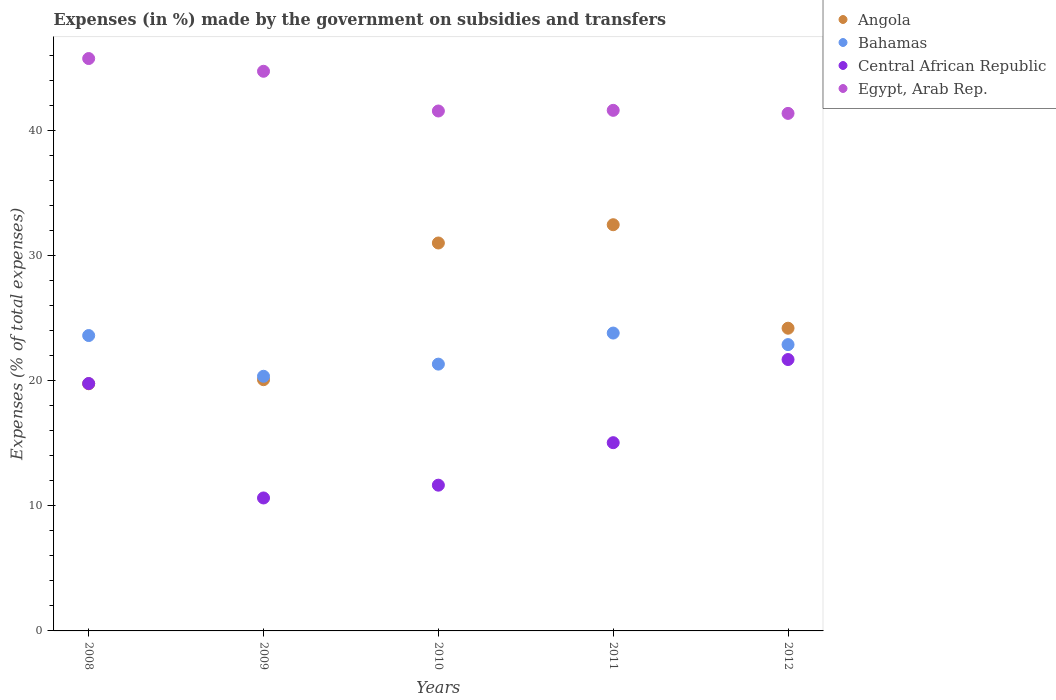How many different coloured dotlines are there?
Provide a succinct answer. 4. What is the percentage of expenses made by the government on subsidies and transfers in Egypt, Arab Rep. in 2009?
Keep it short and to the point. 44.75. Across all years, what is the maximum percentage of expenses made by the government on subsidies and transfers in Egypt, Arab Rep.?
Ensure brevity in your answer.  45.76. Across all years, what is the minimum percentage of expenses made by the government on subsidies and transfers in Central African Republic?
Keep it short and to the point. 10.63. In which year was the percentage of expenses made by the government on subsidies and transfers in Central African Republic maximum?
Make the answer very short. 2012. In which year was the percentage of expenses made by the government on subsidies and transfers in Central African Republic minimum?
Offer a very short reply. 2009. What is the total percentage of expenses made by the government on subsidies and transfers in Egypt, Arab Rep. in the graph?
Provide a succinct answer. 215.08. What is the difference between the percentage of expenses made by the government on subsidies and transfers in Angola in 2011 and that in 2012?
Your answer should be very brief. 8.27. What is the difference between the percentage of expenses made by the government on subsidies and transfers in Central African Republic in 2008 and the percentage of expenses made by the government on subsidies and transfers in Angola in 2009?
Provide a succinct answer. -0.31. What is the average percentage of expenses made by the government on subsidies and transfers in Bahamas per year?
Your response must be concise. 22.4. In the year 2011, what is the difference between the percentage of expenses made by the government on subsidies and transfers in Central African Republic and percentage of expenses made by the government on subsidies and transfers in Angola?
Your response must be concise. -17.43. In how many years, is the percentage of expenses made by the government on subsidies and transfers in Central African Republic greater than 8 %?
Provide a succinct answer. 5. What is the ratio of the percentage of expenses made by the government on subsidies and transfers in Egypt, Arab Rep. in 2009 to that in 2010?
Ensure brevity in your answer.  1.08. Is the difference between the percentage of expenses made by the government on subsidies and transfers in Central African Republic in 2009 and 2011 greater than the difference between the percentage of expenses made by the government on subsidies and transfers in Angola in 2009 and 2011?
Give a very brief answer. Yes. What is the difference between the highest and the second highest percentage of expenses made by the government on subsidies and transfers in Bahamas?
Your answer should be compact. 0.2. What is the difference between the highest and the lowest percentage of expenses made by the government on subsidies and transfers in Bahamas?
Offer a terse response. 3.46. Is it the case that in every year, the sum of the percentage of expenses made by the government on subsidies and transfers in Bahamas and percentage of expenses made by the government on subsidies and transfers in Angola  is greater than the sum of percentage of expenses made by the government on subsidies and transfers in Egypt, Arab Rep. and percentage of expenses made by the government on subsidies and transfers in Central African Republic?
Your answer should be very brief. No. Does the percentage of expenses made by the government on subsidies and transfers in Egypt, Arab Rep. monotonically increase over the years?
Your answer should be very brief. No. Is the percentage of expenses made by the government on subsidies and transfers in Egypt, Arab Rep. strictly greater than the percentage of expenses made by the government on subsidies and transfers in Bahamas over the years?
Make the answer very short. Yes. How many dotlines are there?
Provide a short and direct response. 4. How many years are there in the graph?
Offer a very short reply. 5. Does the graph contain any zero values?
Provide a succinct answer. No. Does the graph contain grids?
Keep it short and to the point. No. Where does the legend appear in the graph?
Provide a short and direct response. Top right. What is the title of the graph?
Your answer should be compact. Expenses (in %) made by the government on subsidies and transfers. Does "Sri Lanka" appear as one of the legend labels in the graph?
Your answer should be very brief. No. What is the label or title of the X-axis?
Your response must be concise. Years. What is the label or title of the Y-axis?
Offer a terse response. Expenses (% of total expenses). What is the Expenses (% of total expenses) of Angola in 2008?
Make the answer very short. 19.76. What is the Expenses (% of total expenses) in Bahamas in 2008?
Provide a succinct answer. 23.62. What is the Expenses (% of total expenses) in Central African Republic in 2008?
Make the answer very short. 19.78. What is the Expenses (% of total expenses) of Egypt, Arab Rep. in 2008?
Give a very brief answer. 45.76. What is the Expenses (% of total expenses) of Angola in 2009?
Keep it short and to the point. 20.09. What is the Expenses (% of total expenses) of Bahamas in 2009?
Provide a short and direct response. 20.36. What is the Expenses (% of total expenses) in Central African Republic in 2009?
Offer a terse response. 10.63. What is the Expenses (% of total expenses) of Egypt, Arab Rep. in 2009?
Provide a succinct answer. 44.75. What is the Expenses (% of total expenses) in Angola in 2010?
Make the answer very short. 31.02. What is the Expenses (% of total expenses) of Bahamas in 2010?
Keep it short and to the point. 21.33. What is the Expenses (% of total expenses) of Central African Republic in 2010?
Ensure brevity in your answer.  11.65. What is the Expenses (% of total expenses) of Egypt, Arab Rep. in 2010?
Your answer should be compact. 41.57. What is the Expenses (% of total expenses) of Angola in 2011?
Make the answer very short. 32.48. What is the Expenses (% of total expenses) in Bahamas in 2011?
Your answer should be compact. 23.82. What is the Expenses (% of total expenses) in Central African Republic in 2011?
Your answer should be compact. 15.05. What is the Expenses (% of total expenses) in Egypt, Arab Rep. in 2011?
Provide a succinct answer. 41.62. What is the Expenses (% of total expenses) in Angola in 2012?
Keep it short and to the point. 24.2. What is the Expenses (% of total expenses) of Bahamas in 2012?
Offer a terse response. 22.89. What is the Expenses (% of total expenses) of Central African Republic in 2012?
Offer a very short reply. 21.7. What is the Expenses (% of total expenses) in Egypt, Arab Rep. in 2012?
Offer a very short reply. 41.38. Across all years, what is the maximum Expenses (% of total expenses) of Angola?
Keep it short and to the point. 32.48. Across all years, what is the maximum Expenses (% of total expenses) in Bahamas?
Provide a short and direct response. 23.82. Across all years, what is the maximum Expenses (% of total expenses) of Central African Republic?
Provide a short and direct response. 21.7. Across all years, what is the maximum Expenses (% of total expenses) of Egypt, Arab Rep.?
Provide a short and direct response. 45.76. Across all years, what is the minimum Expenses (% of total expenses) of Angola?
Give a very brief answer. 19.76. Across all years, what is the minimum Expenses (% of total expenses) in Bahamas?
Ensure brevity in your answer.  20.36. Across all years, what is the minimum Expenses (% of total expenses) of Central African Republic?
Your response must be concise. 10.63. Across all years, what is the minimum Expenses (% of total expenses) in Egypt, Arab Rep.?
Provide a short and direct response. 41.38. What is the total Expenses (% of total expenses) in Angola in the graph?
Your answer should be compact. 127.55. What is the total Expenses (% of total expenses) of Bahamas in the graph?
Keep it short and to the point. 112.02. What is the total Expenses (% of total expenses) of Central African Republic in the graph?
Offer a very short reply. 78.81. What is the total Expenses (% of total expenses) in Egypt, Arab Rep. in the graph?
Your answer should be very brief. 215.08. What is the difference between the Expenses (% of total expenses) in Angola in 2008 and that in 2009?
Make the answer very short. -0.33. What is the difference between the Expenses (% of total expenses) in Bahamas in 2008 and that in 2009?
Your response must be concise. 3.26. What is the difference between the Expenses (% of total expenses) in Central African Republic in 2008 and that in 2009?
Offer a very short reply. 9.15. What is the difference between the Expenses (% of total expenses) in Egypt, Arab Rep. in 2008 and that in 2009?
Keep it short and to the point. 1.02. What is the difference between the Expenses (% of total expenses) in Angola in 2008 and that in 2010?
Offer a very short reply. -11.25. What is the difference between the Expenses (% of total expenses) in Bahamas in 2008 and that in 2010?
Offer a very short reply. 2.29. What is the difference between the Expenses (% of total expenses) of Central African Republic in 2008 and that in 2010?
Provide a succinct answer. 8.13. What is the difference between the Expenses (% of total expenses) of Egypt, Arab Rep. in 2008 and that in 2010?
Provide a short and direct response. 4.19. What is the difference between the Expenses (% of total expenses) in Angola in 2008 and that in 2011?
Your answer should be very brief. -12.72. What is the difference between the Expenses (% of total expenses) of Bahamas in 2008 and that in 2011?
Provide a short and direct response. -0.2. What is the difference between the Expenses (% of total expenses) of Central African Republic in 2008 and that in 2011?
Provide a succinct answer. 4.73. What is the difference between the Expenses (% of total expenses) of Egypt, Arab Rep. in 2008 and that in 2011?
Ensure brevity in your answer.  4.14. What is the difference between the Expenses (% of total expenses) in Angola in 2008 and that in 2012?
Offer a terse response. -4.44. What is the difference between the Expenses (% of total expenses) of Bahamas in 2008 and that in 2012?
Offer a terse response. 0.72. What is the difference between the Expenses (% of total expenses) of Central African Republic in 2008 and that in 2012?
Ensure brevity in your answer.  -1.92. What is the difference between the Expenses (% of total expenses) in Egypt, Arab Rep. in 2008 and that in 2012?
Provide a succinct answer. 4.39. What is the difference between the Expenses (% of total expenses) in Angola in 2009 and that in 2010?
Offer a very short reply. -10.93. What is the difference between the Expenses (% of total expenses) of Bahamas in 2009 and that in 2010?
Your answer should be very brief. -0.97. What is the difference between the Expenses (% of total expenses) in Central African Republic in 2009 and that in 2010?
Your response must be concise. -1.02. What is the difference between the Expenses (% of total expenses) of Egypt, Arab Rep. in 2009 and that in 2010?
Your response must be concise. 3.18. What is the difference between the Expenses (% of total expenses) in Angola in 2009 and that in 2011?
Provide a succinct answer. -12.39. What is the difference between the Expenses (% of total expenses) in Bahamas in 2009 and that in 2011?
Ensure brevity in your answer.  -3.46. What is the difference between the Expenses (% of total expenses) in Central African Republic in 2009 and that in 2011?
Provide a succinct answer. -4.42. What is the difference between the Expenses (% of total expenses) of Egypt, Arab Rep. in 2009 and that in 2011?
Offer a terse response. 3.12. What is the difference between the Expenses (% of total expenses) in Angola in 2009 and that in 2012?
Keep it short and to the point. -4.12. What is the difference between the Expenses (% of total expenses) in Bahamas in 2009 and that in 2012?
Make the answer very short. -2.53. What is the difference between the Expenses (% of total expenses) of Central African Republic in 2009 and that in 2012?
Offer a very short reply. -11.07. What is the difference between the Expenses (% of total expenses) of Egypt, Arab Rep. in 2009 and that in 2012?
Provide a succinct answer. 3.37. What is the difference between the Expenses (% of total expenses) of Angola in 2010 and that in 2011?
Ensure brevity in your answer.  -1.46. What is the difference between the Expenses (% of total expenses) of Bahamas in 2010 and that in 2011?
Offer a terse response. -2.48. What is the difference between the Expenses (% of total expenses) of Central African Republic in 2010 and that in 2011?
Offer a terse response. -3.4. What is the difference between the Expenses (% of total expenses) in Egypt, Arab Rep. in 2010 and that in 2011?
Give a very brief answer. -0.05. What is the difference between the Expenses (% of total expenses) of Angola in 2010 and that in 2012?
Make the answer very short. 6.81. What is the difference between the Expenses (% of total expenses) of Bahamas in 2010 and that in 2012?
Your response must be concise. -1.56. What is the difference between the Expenses (% of total expenses) of Central African Republic in 2010 and that in 2012?
Give a very brief answer. -10.05. What is the difference between the Expenses (% of total expenses) of Egypt, Arab Rep. in 2010 and that in 2012?
Offer a very short reply. 0.19. What is the difference between the Expenses (% of total expenses) in Angola in 2011 and that in 2012?
Offer a terse response. 8.27. What is the difference between the Expenses (% of total expenses) of Bahamas in 2011 and that in 2012?
Make the answer very short. 0.92. What is the difference between the Expenses (% of total expenses) of Central African Republic in 2011 and that in 2012?
Your answer should be compact. -6.65. What is the difference between the Expenses (% of total expenses) of Egypt, Arab Rep. in 2011 and that in 2012?
Offer a very short reply. 0.24. What is the difference between the Expenses (% of total expenses) of Angola in 2008 and the Expenses (% of total expenses) of Bahamas in 2009?
Your response must be concise. -0.6. What is the difference between the Expenses (% of total expenses) of Angola in 2008 and the Expenses (% of total expenses) of Central African Republic in 2009?
Your answer should be very brief. 9.13. What is the difference between the Expenses (% of total expenses) of Angola in 2008 and the Expenses (% of total expenses) of Egypt, Arab Rep. in 2009?
Your response must be concise. -24.98. What is the difference between the Expenses (% of total expenses) in Bahamas in 2008 and the Expenses (% of total expenses) in Central African Republic in 2009?
Offer a very short reply. 12.99. What is the difference between the Expenses (% of total expenses) of Bahamas in 2008 and the Expenses (% of total expenses) of Egypt, Arab Rep. in 2009?
Ensure brevity in your answer.  -21.13. What is the difference between the Expenses (% of total expenses) of Central African Republic in 2008 and the Expenses (% of total expenses) of Egypt, Arab Rep. in 2009?
Your answer should be very brief. -24.97. What is the difference between the Expenses (% of total expenses) in Angola in 2008 and the Expenses (% of total expenses) in Bahamas in 2010?
Offer a very short reply. -1.57. What is the difference between the Expenses (% of total expenses) in Angola in 2008 and the Expenses (% of total expenses) in Central African Republic in 2010?
Give a very brief answer. 8.11. What is the difference between the Expenses (% of total expenses) in Angola in 2008 and the Expenses (% of total expenses) in Egypt, Arab Rep. in 2010?
Give a very brief answer. -21.81. What is the difference between the Expenses (% of total expenses) of Bahamas in 2008 and the Expenses (% of total expenses) of Central African Republic in 2010?
Make the answer very short. 11.96. What is the difference between the Expenses (% of total expenses) of Bahamas in 2008 and the Expenses (% of total expenses) of Egypt, Arab Rep. in 2010?
Provide a succinct answer. -17.95. What is the difference between the Expenses (% of total expenses) of Central African Republic in 2008 and the Expenses (% of total expenses) of Egypt, Arab Rep. in 2010?
Your answer should be compact. -21.79. What is the difference between the Expenses (% of total expenses) in Angola in 2008 and the Expenses (% of total expenses) in Bahamas in 2011?
Offer a very short reply. -4.05. What is the difference between the Expenses (% of total expenses) of Angola in 2008 and the Expenses (% of total expenses) of Central African Republic in 2011?
Provide a short and direct response. 4.71. What is the difference between the Expenses (% of total expenses) of Angola in 2008 and the Expenses (% of total expenses) of Egypt, Arab Rep. in 2011?
Ensure brevity in your answer.  -21.86. What is the difference between the Expenses (% of total expenses) of Bahamas in 2008 and the Expenses (% of total expenses) of Central African Republic in 2011?
Offer a terse response. 8.57. What is the difference between the Expenses (% of total expenses) in Bahamas in 2008 and the Expenses (% of total expenses) in Egypt, Arab Rep. in 2011?
Make the answer very short. -18.01. What is the difference between the Expenses (% of total expenses) of Central African Republic in 2008 and the Expenses (% of total expenses) of Egypt, Arab Rep. in 2011?
Ensure brevity in your answer.  -21.84. What is the difference between the Expenses (% of total expenses) of Angola in 2008 and the Expenses (% of total expenses) of Bahamas in 2012?
Ensure brevity in your answer.  -3.13. What is the difference between the Expenses (% of total expenses) in Angola in 2008 and the Expenses (% of total expenses) in Central African Republic in 2012?
Provide a short and direct response. -1.94. What is the difference between the Expenses (% of total expenses) of Angola in 2008 and the Expenses (% of total expenses) of Egypt, Arab Rep. in 2012?
Provide a short and direct response. -21.62. What is the difference between the Expenses (% of total expenses) of Bahamas in 2008 and the Expenses (% of total expenses) of Central African Republic in 2012?
Provide a short and direct response. 1.92. What is the difference between the Expenses (% of total expenses) in Bahamas in 2008 and the Expenses (% of total expenses) in Egypt, Arab Rep. in 2012?
Your answer should be very brief. -17.76. What is the difference between the Expenses (% of total expenses) in Central African Republic in 2008 and the Expenses (% of total expenses) in Egypt, Arab Rep. in 2012?
Make the answer very short. -21.6. What is the difference between the Expenses (% of total expenses) of Angola in 2009 and the Expenses (% of total expenses) of Bahamas in 2010?
Give a very brief answer. -1.24. What is the difference between the Expenses (% of total expenses) of Angola in 2009 and the Expenses (% of total expenses) of Central African Republic in 2010?
Provide a short and direct response. 8.43. What is the difference between the Expenses (% of total expenses) of Angola in 2009 and the Expenses (% of total expenses) of Egypt, Arab Rep. in 2010?
Your answer should be compact. -21.48. What is the difference between the Expenses (% of total expenses) in Bahamas in 2009 and the Expenses (% of total expenses) in Central African Republic in 2010?
Make the answer very short. 8.71. What is the difference between the Expenses (% of total expenses) in Bahamas in 2009 and the Expenses (% of total expenses) in Egypt, Arab Rep. in 2010?
Ensure brevity in your answer.  -21.21. What is the difference between the Expenses (% of total expenses) in Central African Republic in 2009 and the Expenses (% of total expenses) in Egypt, Arab Rep. in 2010?
Ensure brevity in your answer.  -30.94. What is the difference between the Expenses (% of total expenses) of Angola in 2009 and the Expenses (% of total expenses) of Bahamas in 2011?
Your response must be concise. -3.73. What is the difference between the Expenses (% of total expenses) of Angola in 2009 and the Expenses (% of total expenses) of Central African Republic in 2011?
Provide a short and direct response. 5.04. What is the difference between the Expenses (% of total expenses) in Angola in 2009 and the Expenses (% of total expenses) in Egypt, Arab Rep. in 2011?
Your response must be concise. -21.53. What is the difference between the Expenses (% of total expenses) of Bahamas in 2009 and the Expenses (% of total expenses) of Central African Republic in 2011?
Your response must be concise. 5.31. What is the difference between the Expenses (% of total expenses) of Bahamas in 2009 and the Expenses (% of total expenses) of Egypt, Arab Rep. in 2011?
Keep it short and to the point. -21.26. What is the difference between the Expenses (% of total expenses) of Central African Republic in 2009 and the Expenses (% of total expenses) of Egypt, Arab Rep. in 2011?
Provide a succinct answer. -30.99. What is the difference between the Expenses (% of total expenses) in Angola in 2009 and the Expenses (% of total expenses) in Bahamas in 2012?
Make the answer very short. -2.8. What is the difference between the Expenses (% of total expenses) in Angola in 2009 and the Expenses (% of total expenses) in Central African Republic in 2012?
Give a very brief answer. -1.61. What is the difference between the Expenses (% of total expenses) of Angola in 2009 and the Expenses (% of total expenses) of Egypt, Arab Rep. in 2012?
Your answer should be very brief. -21.29. What is the difference between the Expenses (% of total expenses) in Bahamas in 2009 and the Expenses (% of total expenses) in Central African Republic in 2012?
Offer a terse response. -1.34. What is the difference between the Expenses (% of total expenses) in Bahamas in 2009 and the Expenses (% of total expenses) in Egypt, Arab Rep. in 2012?
Provide a succinct answer. -21.02. What is the difference between the Expenses (% of total expenses) of Central African Republic in 2009 and the Expenses (% of total expenses) of Egypt, Arab Rep. in 2012?
Provide a short and direct response. -30.75. What is the difference between the Expenses (% of total expenses) in Angola in 2010 and the Expenses (% of total expenses) in Bahamas in 2011?
Your answer should be very brief. 7.2. What is the difference between the Expenses (% of total expenses) of Angola in 2010 and the Expenses (% of total expenses) of Central African Republic in 2011?
Give a very brief answer. 15.97. What is the difference between the Expenses (% of total expenses) of Angola in 2010 and the Expenses (% of total expenses) of Egypt, Arab Rep. in 2011?
Offer a very short reply. -10.61. What is the difference between the Expenses (% of total expenses) in Bahamas in 2010 and the Expenses (% of total expenses) in Central African Republic in 2011?
Your answer should be compact. 6.28. What is the difference between the Expenses (% of total expenses) in Bahamas in 2010 and the Expenses (% of total expenses) in Egypt, Arab Rep. in 2011?
Your answer should be compact. -20.29. What is the difference between the Expenses (% of total expenses) in Central African Republic in 2010 and the Expenses (% of total expenses) in Egypt, Arab Rep. in 2011?
Make the answer very short. -29.97. What is the difference between the Expenses (% of total expenses) in Angola in 2010 and the Expenses (% of total expenses) in Bahamas in 2012?
Give a very brief answer. 8.12. What is the difference between the Expenses (% of total expenses) of Angola in 2010 and the Expenses (% of total expenses) of Central African Republic in 2012?
Ensure brevity in your answer.  9.32. What is the difference between the Expenses (% of total expenses) in Angola in 2010 and the Expenses (% of total expenses) in Egypt, Arab Rep. in 2012?
Give a very brief answer. -10.36. What is the difference between the Expenses (% of total expenses) in Bahamas in 2010 and the Expenses (% of total expenses) in Central African Republic in 2012?
Your answer should be very brief. -0.37. What is the difference between the Expenses (% of total expenses) of Bahamas in 2010 and the Expenses (% of total expenses) of Egypt, Arab Rep. in 2012?
Ensure brevity in your answer.  -20.05. What is the difference between the Expenses (% of total expenses) in Central African Republic in 2010 and the Expenses (% of total expenses) in Egypt, Arab Rep. in 2012?
Offer a terse response. -29.73. What is the difference between the Expenses (% of total expenses) of Angola in 2011 and the Expenses (% of total expenses) of Bahamas in 2012?
Offer a terse response. 9.59. What is the difference between the Expenses (% of total expenses) of Angola in 2011 and the Expenses (% of total expenses) of Central African Republic in 2012?
Provide a succinct answer. 10.78. What is the difference between the Expenses (% of total expenses) of Angola in 2011 and the Expenses (% of total expenses) of Egypt, Arab Rep. in 2012?
Your answer should be very brief. -8.9. What is the difference between the Expenses (% of total expenses) of Bahamas in 2011 and the Expenses (% of total expenses) of Central African Republic in 2012?
Offer a terse response. 2.12. What is the difference between the Expenses (% of total expenses) in Bahamas in 2011 and the Expenses (% of total expenses) in Egypt, Arab Rep. in 2012?
Your response must be concise. -17.56. What is the difference between the Expenses (% of total expenses) in Central African Republic in 2011 and the Expenses (% of total expenses) in Egypt, Arab Rep. in 2012?
Offer a very short reply. -26.33. What is the average Expenses (% of total expenses) in Angola per year?
Provide a short and direct response. 25.51. What is the average Expenses (% of total expenses) in Bahamas per year?
Your response must be concise. 22.4. What is the average Expenses (% of total expenses) in Central African Republic per year?
Provide a succinct answer. 15.76. What is the average Expenses (% of total expenses) in Egypt, Arab Rep. per year?
Make the answer very short. 43.02. In the year 2008, what is the difference between the Expenses (% of total expenses) in Angola and Expenses (% of total expenses) in Bahamas?
Your response must be concise. -3.85. In the year 2008, what is the difference between the Expenses (% of total expenses) in Angola and Expenses (% of total expenses) in Central African Republic?
Give a very brief answer. -0.02. In the year 2008, what is the difference between the Expenses (% of total expenses) in Angola and Expenses (% of total expenses) in Egypt, Arab Rep.?
Ensure brevity in your answer.  -26. In the year 2008, what is the difference between the Expenses (% of total expenses) of Bahamas and Expenses (% of total expenses) of Central African Republic?
Offer a very short reply. 3.84. In the year 2008, what is the difference between the Expenses (% of total expenses) in Bahamas and Expenses (% of total expenses) in Egypt, Arab Rep.?
Make the answer very short. -22.15. In the year 2008, what is the difference between the Expenses (% of total expenses) in Central African Republic and Expenses (% of total expenses) in Egypt, Arab Rep.?
Keep it short and to the point. -25.98. In the year 2009, what is the difference between the Expenses (% of total expenses) in Angola and Expenses (% of total expenses) in Bahamas?
Ensure brevity in your answer.  -0.27. In the year 2009, what is the difference between the Expenses (% of total expenses) in Angola and Expenses (% of total expenses) in Central African Republic?
Offer a terse response. 9.46. In the year 2009, what is the difference between the Expenses (% of total expenses) in Angola and Expenses (% of total expenses) in Egypt, Arab Rep.?
Provide a short and direct response. -24.66. In the year 2009, what is the difference between the Expenses (% of total expenses) of Bahamas and Expenses (% of total expenses) of Central African Republic?
Your response must be concise. 9.73. In the year 2009, what is the difference between the Expenses (% of total expenses) of Bahamas and Expenses (% of total expenses) of Egypt, Arab Rep.?
Provide a succinct answer. -24.39. In the year 2009, what is the difference between the Expenses (% of total expenses) of Central African Republic and Expenses (% of total expenses) of Egypt, Arab Rep.?
Offer a very short reply. -34.12. In the year 2010, what is the difference between the Expenses (% of total expenses) of Angola and Expenses (% of total expenses) of Bahamas?
Make the answer very short. 9.69. In the year 2010, what is the difference between the Expenses (% of total expenses) in Angola and Expenses (% of total expenses) in Central African Republic?
Give a very brief answer. 19.36. In the year 2010, what is the difference between the Expenses (% of total expenses) of Angola and Expenses (% of total expenses) of Egypt, Arab Rep.?
Give a very brief answer. -10.55. In the year 2010, what is the difference between the Expenses (% of total expenses) of Bahamas and Expenses (% of total expenses) of Central African Republic?
Your response must be concise. 9.68. In the year 2010, what is the difference between the Expenses (% of total expenses) of Bahamas and Expenses (% of total expenses) of Egypt, Arab Rep.?
Your answer should be very brief. -20.24. In the year 2010, what is the difference between the Expenses (% of total expenses) in Central African Republic and Expenses (% of total expenses) in Egypt, Arab Rep.?
Give a very brief answer. -29.92. In the year 2011, what is the difference between the Expenses (% of total expenses) of Angola and Expenses (% of total expenses) of Bahamas?
Provide a short and direct response. 8.66. In the year 2011, what is the difference between the Expenses (% of total expenses) in Angola and Expenses (% of total expenses) in Central African Republic?
Ensure brevity in your answer.  17.43. In the year 2011, what is the difference between the Expenses (% of total expenses) in Angola and Expenses (% of total expenses) in Egypt, Arab Rep.?
Offer a terse response. -9.14. In the year 2011, what is the difference between the Expenses (% of total expenses) in Bahamas and Expenses (% of total expenses) in Central African Republic?
Your response must be concise. 8.77. In the year 2011, what is the difference between the Expenses (% of total expenses) of Bahamas and Expenses (% of total expenses) of Egypt, Arab Rep.?
Your answer should be compact. -17.81. In the year 2011, what is the difference between the Expenses (% of total expenses) in Central African Republic and Expenses (% of total expenses) in Egypt, Arab Rep.?
Ensure brevity in your answer.  -26.57. In the year 2012, what is the difference between the Expenses (% of total expenses) of Angola and Expenses (% of total expenses) of Bahamas?
Make the answer very short. 1.31. In the year 2012, what is the difference between the Expenses (% of total expenses) in Angola and Expenses (% of total expenses) in Central African Republic?
Make the answer very short. 2.5. In the year 2012, what is the difference between the Expenses (% of total expenses) of Angola and Expenses (% of total expenses) of Egypt, Arab Rep.?
Give a very brief answer. -17.18. In the year 2012, what is the difference between the Expenses (% of total expenses) in Bahamas and Expenses (% of total expenses) in Central African Republic?
Ensure brevity in your answer.  1.19. In the year 2012, what is the difference between the Expenses (% of total expenses) of Bahamas and Expenses (% of total expenses) of Egypt, Arab Rep.?
Provide a succinct answer. -18.49. In the year 2012, what is the difference between the Expenses (% of total expenses) in Central African Republic and Expenses (% of total expenses) in Egypt, Arab Rep.?
Provide a short and direct response. -19.68. What is the ratio of the Expenses (% of total expenses) in Angola in 2008 to that in 2009?
Give a very brief answer. 0.98. What is the ratio of the Expenses (% of total expenses) of Bahamas in 2008 to that in 2009?
Your answer should be very brief. 1.16. What is the ratio of the Expenses (% of total expenses) of Central African Republic in 2008 to that in 2009?
Your answer should be compact. 1.86. What is the ratio of the Expenses (% of total expenses) of Egypt, Arab Rep. in 2008 to that in 2009?
Your answer should be very brief. 1.02. What is the ratio of the Expenses (% of total expenses) in Angola in 2008 to that in 2010?
Offer a terse response. 0.64. What is the ratio of the Expenses (% of total expenses) of Bahamas in 2008 to that in 2010?
Your answer should be very brief. 1.11. What is the ratio of the Expenses (% of total expenses) in Central African Republic in 2008 to that in 2010?
Provide a short and direct response. 1.7. What is the ratio of the Expenses (% of total expenses) of Egypt, Arab Rep. in 2008 to that in 2010?
Provide a succinct answer. 1.1. What is the ratio of the Expenses (% of total expenses) in Angola in 2008 to that in 2011?
Provide a short and direct response. 0.61. What is the ratio of the Expenses (% of total expenses) in Bahamas in 2008 to that in 2011?
Ensure brevity in your answer.  0.99. What is the ratio of the Expenses (% of total expenses) of Central African Republic in 2008 to that in 2011?
Your answer should be compact. 1.31. What is the ratio of the Expenses (% of total expenses) in Egypt, Arab Rep. in 2008 to that in 2011?
Your answer should be compact. 1.1. What is the ratio of the Expenses (% of total expenses) of Angola in 2008 to that in 2012?
Make the answer very short. 0.82. What is the ratio of the Expenses (% of total expenses) of Bahamas in 2008 to that in 2012?
Your answer should be very brief. 1.03. What is the ratio of the Expenses (% of total expenses) of Central African Republic in 2008 to that in 2012?
Keep it short and to the point. 0.91. What is the ratio of the Expenses (% of total expenses) of Egypt, Arab Rep. in 2008 to that in 2012?
Provide a short and direct response. 1.11. What is the ratio of the Expenses (% of total expenses) in Angola in 2009 to that in 2010?
Provide a short and direct response. 0.65. What is the ratio of the Expenses (% of total expenses) in Bahamas in 2009 to that in 2010?
Offer a terse response. 0.95. What is the ratio of the Expenses (% of total expenses) in Central African Republic in 2009 to that in 2010?
Provide a short and direct response. 0.91. What is the ratio of the Expenses (% of total expenses) in Egypt, Arab Rep. in 2009 to that in 2010?
Offer a terse response. 1.08. What is the ratio of the Expenses (% of total expenses) of Angola in 2009 to that in 2011?
Provide a short and direct response. 0.62. What is the ratio of the Expenses (% of total expenses) in Bahamas in 2009 to that in 2011?
Provide a short and direct response. 0.85. What is the ratio of the Expenses (% of total expenses) in Central African Republic in 2009 to that in 2011?
Your answer should be very brief. 0.71. What is the ratio of the Expenses (% of total expenses) of Egypt, Arab Rep. in 2009 to that in 2011?
Keep it short and to the point. 1.07. What is the ratio of the Expenses (% of total expenses) of Angola in 2009 to that in 2012?
Make the answer very short. 0.83. What is the ratio of the Expenses (% of total expenses) in Bahamas in 2009 to that in 2012?
Provide a succinct answer. 0.89. What is the ratio of the Expenses (% of total expenses) in Central African Republic in 2009 to that in 2012?
Keep it short and to the point. 0.49. What is the ratio of the Expenses (% of total expenses) in Egypt, Arab Rep. in 2009 to that in 2012?
Offer a terse response. 1.08. What is the ratio of the Expenses (% of total expenses) of Angola in 2010 to that in 2011?
Give a very brief answer. 0.95. What is the ratio of the Expenses (% of total expenses) in Bahamas in 2010 to that in 2011?
Your response must be concise. 0.9. What is the ratio of the Expenses (% of total expenses) of Central African Republic in 2010 to that in 2011?
Your answer should be compact. 0.77. What is the ratio of the Expenses (% of total expenses) in Angola in 2010 to that in 2012?
Keep it short and to the point. 1.28. What is the ratio of the Expenses (% of total expenses) in Bahamas in 2010 to that in 2012?
Your answer should be very brief. 0.93. What is the ratio of the Expenses (% of total expenses) in Central African Republic in 2010 to that in 2012?
Keep it short and to the point. 0.54. What is the ratio of the Expenses (% of total expenses) of Egypt, Arab Rep. in 2010 to that in 2012?
Ensure brevity in your answer.  1. What is the ratio of the Expenses (% of total expenses) of Angola in 2011 to that in 2012?
Your answer should be very brief. 1.34. What is the ratio of the Expenses (% of total expenses) in Bahamas in 2011 to that in 2012?
Give a very brief answer. 1.04. What is the ratio of the Expenses (% of total expenses) in Central African Republic in 2011 to that in 2012?
Your answer should be compact. 0.69. What is the ratio of the Expenses (% of total expenses) of Egypt, Arab Rep. in 2011 to that in 2012?
Your answer should be compact. 1.01. What is the difference between the highest and the second highest Expenses (% of total expenses) in Angola?
Give a very brief answer. 1.46. What is the difference between the highest and the second highest Expenses (% of total expenses) in Bahamas?
Provide a succinct answer. 0.2. What is the difference between the highest and the second highest Expenses (% of total expenses) of Central African Republic?
Offer a very short reply. 1.92. What is the difference between the highest and the second highest Expenses (% of total expenses) of Egypt, Arab Rep.?
Your answer should be very brief. 1.02. What is the difference between the highest and the lowest Expenses (% of total expenses) in Angola?
Ensure brevity in your answer.  12.72. What is the difference between the highest and the lowest Expenses (% of total expenses) of Bahamas?
Offer a very short reply. 3.46. What is the difference between the highest and the lowest Expenses (% of total expenses) in Central African Republic?
Give a very brief answer. 11.07. What is the difference between the highest and the lowest Expenses (% of total expenses) in Egypt, Arab Rep.?
Your answer should be very brief. 4.39. 